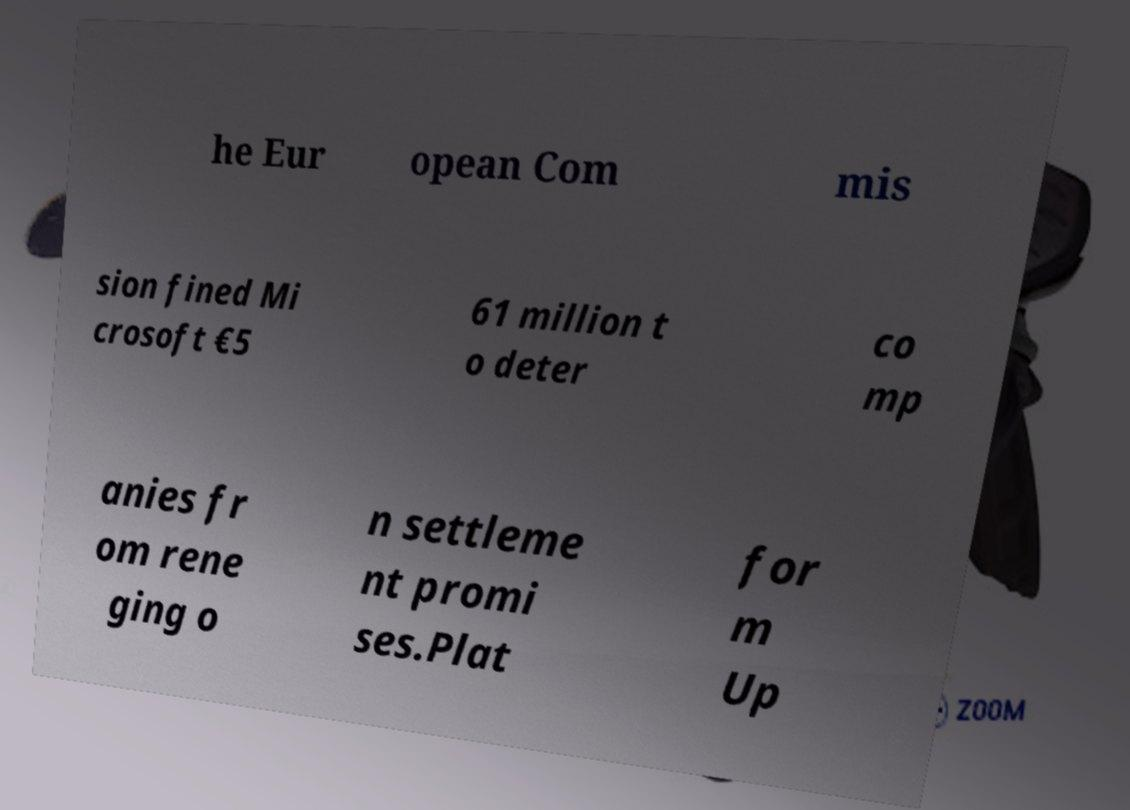There's text embedded in this image that I need extracted. Can you transcribe it verbatim? he Eur opean Com mis sion fined Mi crosoft €5 61 million t o deter co mp anies fr om rene ging o n settleme nt promi ses.Plat for m Up 